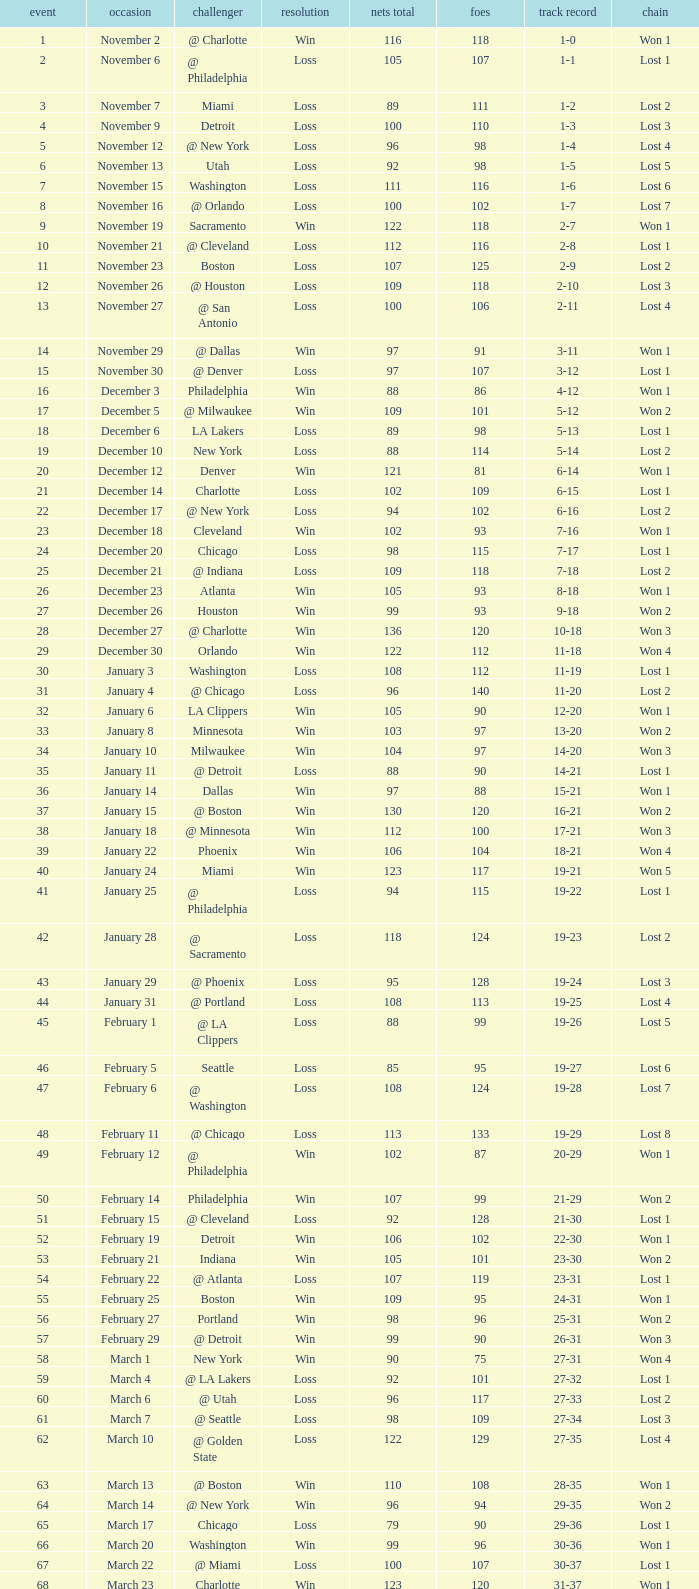How many opponents were there in a game higher than 20 on January 28? 124.0. Help me parse the entirety of this table. {'header': ['event', 'occasion', 'challenger', 'resolution', 'nets total', 'foes', 'track record', 'chain'], 'rows': [['1', 'November 2', '@ Charlotte', 'Win', '116', '118', '1-0', 'Won 1'], ['2', 'November 6', '@ Philadelphia', 'Loss', '105', '107', '1-1', 'Lost 1'], ['3', 'November 7', 'Miami', 'Loss', '89', '111', '1-2', 'Lost 2'], ['4', 'November 9', 'Detroit', 'Loss', '100', '110', '1-3', 'Lost 3'], ['5', 'November 12', '@ New York', 'Loss', '96', '98', '1-4', 'Lost 4'], ['6', 'November 13', 'Utah', 'Loss', '92', '98', '1-5', 'Lost 5'], ['7', 'November 15', 'Washington', 'Loss', '111', '116', '1-6', 'Lost 6'], ['8', 'November 16', '@ Orlando', 'Loss', '100', '102', '1-7', 'Lost 7'], ['9', 'November 19', 'Sacramento', 'Win', '122', '118', '2-7', 'Won 1'], ['10', 'November 21', '@ Cleveland', 'Loss', '112', '116', '2-8', 'Lost 1'], ['11', 'November 23', 'Boston', 'Loss', '107', '125', '2-9', 'Lost 2'], ['12', 'November 26', '@ Houston', 'Loss', '109', '118', '2-10', 'Lost 3'], ['13', 'November 27', '@ San Antonio', 'Loss', '100', '106', '2-11', 'Lost 4'], ['14', 'November 29', '@ Dallas', 'Win', '97', '91', '3-11', 'Won 1'], ['15', 'November 30', '@ Denver', 'Loss', '97', '107', '3-12', 'Lost 1'], ['16', 'December 3', 'Philadelphia', 'Win', '88', '86', '4-12', 'Won 1'], ['17', 'December 5', '@ Milwaukee', 'Win', '109', '101', '5-12', 'Won 2'], ['18', 'December 6', 'LA Lakers', 'Loss', '89', '98', '5-13', 'Lost 1'], ['19', 'December 10', 'New York', 'Loss', '88', '114', '5-14', 'Lost 2'], ['20', 'December 12', 'Denver', 'Win', '121', '81', '6-14', 'Won 1'], ['21', 'December 14', 'Charlotte', 'Loss', '102', '109', '6-15', 'Lost 1'], ['22', 'December 17', '@ New York', 'Loss', '94', '102', '6-16', 'Lost 2'], ['23', 'December 18', 'Cleveland', 'Win', '102', '93', '7-16', 'Won 1'], ['24', 'December 20', 'Chicago', 'Loss', '98', '115', '7-17', 'Lost 1'], ['25', 'December 21', '@ Indiana', 'Loss', '109', '118', '7-18', 'Lost 2'], ['26', 'December 23', 'Atlanta', 'Win', '105', '93', '8-18', 'Won 1'], ['27', 'December 26', 'Houston', 'Win', '99', '93', '9-18', 'Won 2'], ['28', 'December 27', '@ Charlotte', 'Win', '136', '120', '10-18', 'Won 3'], ['29', 'December 30', 'Orlando', 'Win', '122', '112', '11-18', 'Won 4'], ['30', 'January 3', 'Washington', 'Loss', '108', '112', '11-19', 'Lost 1'], ['31', 'January 4', '@ Chicago', 'Loss', '96', '140', '11-20', 'Lost 2'], ['32', 'January 6', 'LA Clippers', 'Win', '105', '90', '12-20', 'Won 1'], ['33', 'January 8', 'Minnesota', 'Win', '103', '97', '13-20', 'Won 2'], ['34', 'January 10', 'Milwaukee', 'Win', '104', '97', '14-20', 'Won 3'], ['35', 'January 11', '@ Detroit', 'Loss', '88', '90', '14-21', 'Lost 1'], ['36', 'January 14', 'Dallas', 'Win', '97', '88', '15-21', 'Won 1'], ['37', 'January 15', '@ Boston', 'Win', '130', '120', '16-21', 'Won 2'], ['38', 'January 18', '@ Minnesota', 'Win', '112', '100', '17-21', 'Won 3'], ['39', 'January 22', 'Phoenix', 'Win', '106', '104', '18-21', 'Won 4'], ['40', 'January 24', 'Miami', 'Win', '123', '117', '19-21', 'Won 5'], ['41', 'January 25', '@ Philadelphia', 'Loss', '94', '115', '19-22', 'Lost 1'], ['42', 'January 28', '@ Sacramento', 'Loss', '118', '124', '19-23', 'Lost 2'], ['43', 'January 29', '@ Phoenix', 'Loss', '95', '128', '19-24', 'Lost 3'], ['44', 'January 31', '@ Portland', 'Loss', '108', '113', '19-25', 'Lost 4'], ['45', 'February 1', '@ LA Clippers', 'Loss', '88', '99', '19-26', 'Lost 5'], ['46', 'February 5', 'Seattle', 'Loss', '85', '95', '19-27', 'Lost 6'], ['47', 'February 6', '@ Washington', 'Loss', '108', '124', '19-28', 'Lost 7'], ['48', 'February 11', '@ Chicago', 'Loss', '113', '133', '19-29', 'Lost 8'], ['49', 'February 12', '@ Philadelphia', 'Win', '102', '87', '20-29', 'Won 1'], ['50', 'February 14', 'Philadelphia', 'Win', '107', '99', '21-29', 'Won 2'], ['51', 'February 15', '@ Cleveland', 'Loss', '92', '128', '21-30', 'Lost 1'], ['52', 'February 19', 'Detroit', 'Win', '106', '102', '22-30', 'Won 1'], ['53', 'February 21', 'Indiana', 'Win', '105', '101', '23-30', 'Won 2'], ['54', 'February 22', '@ Atlanta', 'Loss', '107', '119', '23-31', 'Lost 1'], ['55', 'February 25', 'Boston', 'Win', '109', '95', '24-31', 'Won 1'], ['56', 'February 27', 'Portland', 'Win', '98', '96', '25-31', 'Won 2'], ['57', 'February 29', '@ Detroit', 'Win', '99', '90', '26-31', 'Won 3'], ['58', 'March 1', 'New York', 'Win', '90', '75', '27-31', 'Won 4'], ['59', 'March 4', '@ LA Lakers', 'Loss', '92', '101', '27-32', 'Lost 1'], ['60', 'March 6', '@ Utah', 'Loss', '96', '117', '27-33', 'Lost 2'], ['61', 'March 7', '@ Seattle', 'Loss', '98', '109', '27-34', 'Lost 3'], ['62', 'March 10', '@ Golden State', 'Loss', '122', '129', '27-35', 'Lost 4'], ['63', 'March 13', '@ Boston', 'Win', '110', '108', '28-35', 'Won 1'], ['64', 'March 14', '@ New York', 'Win', '96', '94', '29-35', 'Won 2'], ['65', 'March 17', 'Chicago', 'Loss', '79', '90', '29-36', 'Lost 1'], ['66', 'March 20', 'Washington', 'Win', '99', '96', '30-36', 'Won 1'], ['67', 'March 22', '@ Miami', 'Loss', '100', '107', '30-37', 'Lost 1'], ['68', 'March 23', 'Charlotte', 'Win', '123', '120', '31-37', 'Won 1'], ['69', 'March 25', 'Boston', 'Loss', '110', '118', '31-38', 'Lost 1'], ['70', 'March 28', 'Golden State', 'Loss', '148', '153', '31-39', 'Lost 2'], ['71', 'March 30', 'San Antonio', 'Win', '117', '109', '32-39', 'Won 1'], ['72', 'April 1', '@ Milwaukee', 'Win', '121', '117', '33-39', 'Won 2'], ['73', 'April 3', 'Milwaukee', 'Win', '122', '103', '34-39', 'Won 3'], ['74', 'April 5', '@ Indiana', 'Win', '128', '120', '35-39', 'Won 4'], ['75', 'April 7', 'Atlanta', 'Loss', '97', '104', '35-40', 'Lost 1'], ['76', 'April 8', '@ Washington', 'Win', '109', '103', '36-40', 'Won 1'], ['77', 'April 10', 'Cleveland', 'Win', '110', '86', '37-40', 'Won 2'], ['78', 'April 11', '@ Atlanta', 'Loss', '98', '118', '37-41', 'Lost 1'], ['79', 'April 13', '@ Orlando', 'Win', '110', '104', '38-41', 'Won 1'], ['80', 'April 14', '@ Miami', 'Win', '105', '100', '39-41', 'Won 2'], ['81', 'April 16', 'Indiana', 'Loss', '113', '119', '39-42', 'Lost 1'], ['82', 'April 18', 'Orlando', 'Win', '127', '111', '40-42', 'Won 1'], ['1', 'April 23', '@ Cleveland', 'Loss', '113', '120', '0-1', 'Lost 1'], ['2', 'April 25', '@ Cleveland', 'Loss', '96', '118', '0-2', 'Lost 2'], ['3', 'April 28', 'Cleveland', 'Win', '109', '104', '1-2', 'Won 1'], ['4', 'April 30', 'Cleveland', 'Loss', '89', '98', '1-3', 'Lost 1']]} 